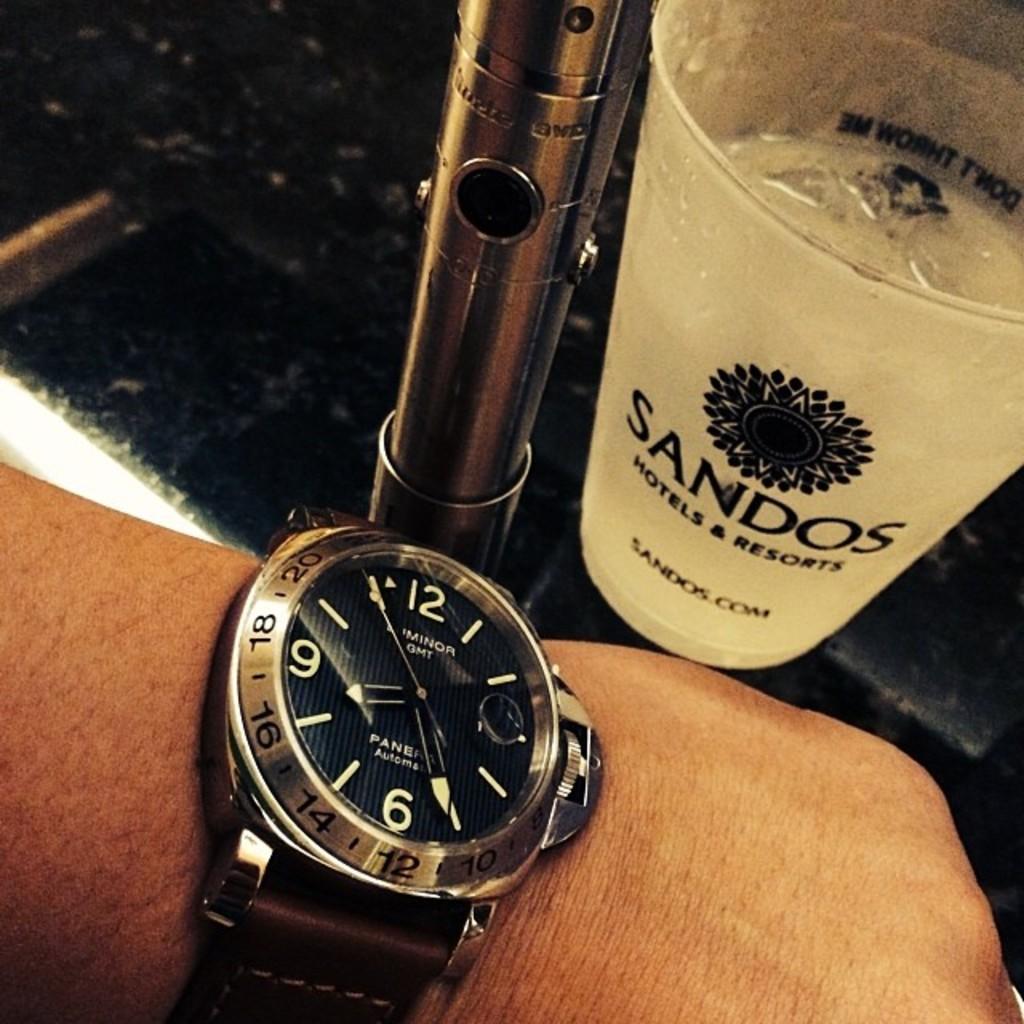What hotel and resort is the cup from?
Your answer should be compact. Sandos. What hotel and resort is the cup from?
Offer a terse response. Sandos. 